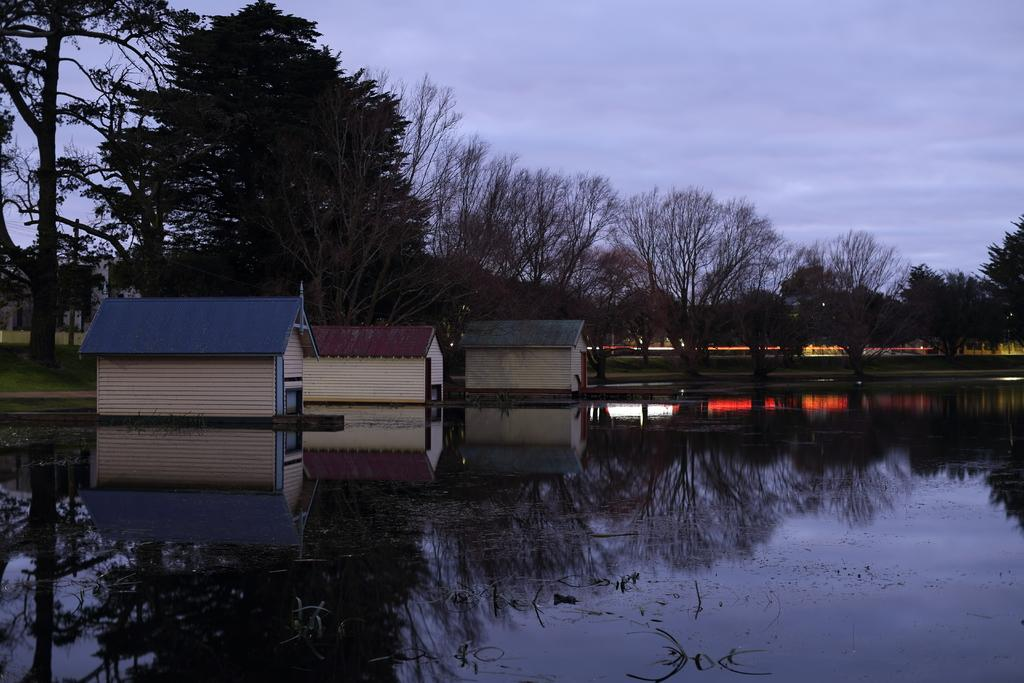What is present in the image that is not a solid structure? There is water visible in the image. What type of structure can be seen in the image? There is a house to the side of the image. What can be seen in the background of the image? There are many trees and the sky visible in the background of the image. Where is the alley located in the image? There is no alley present in the image. What type of country is depicted in the image? The image does not depict a specific country; it shows a house, trees, and water. 